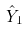Convert formula to latex. <formula><loc_0><loc_0><loc_500><loc_500>\hat { Y } _ { 1 }</formula> 